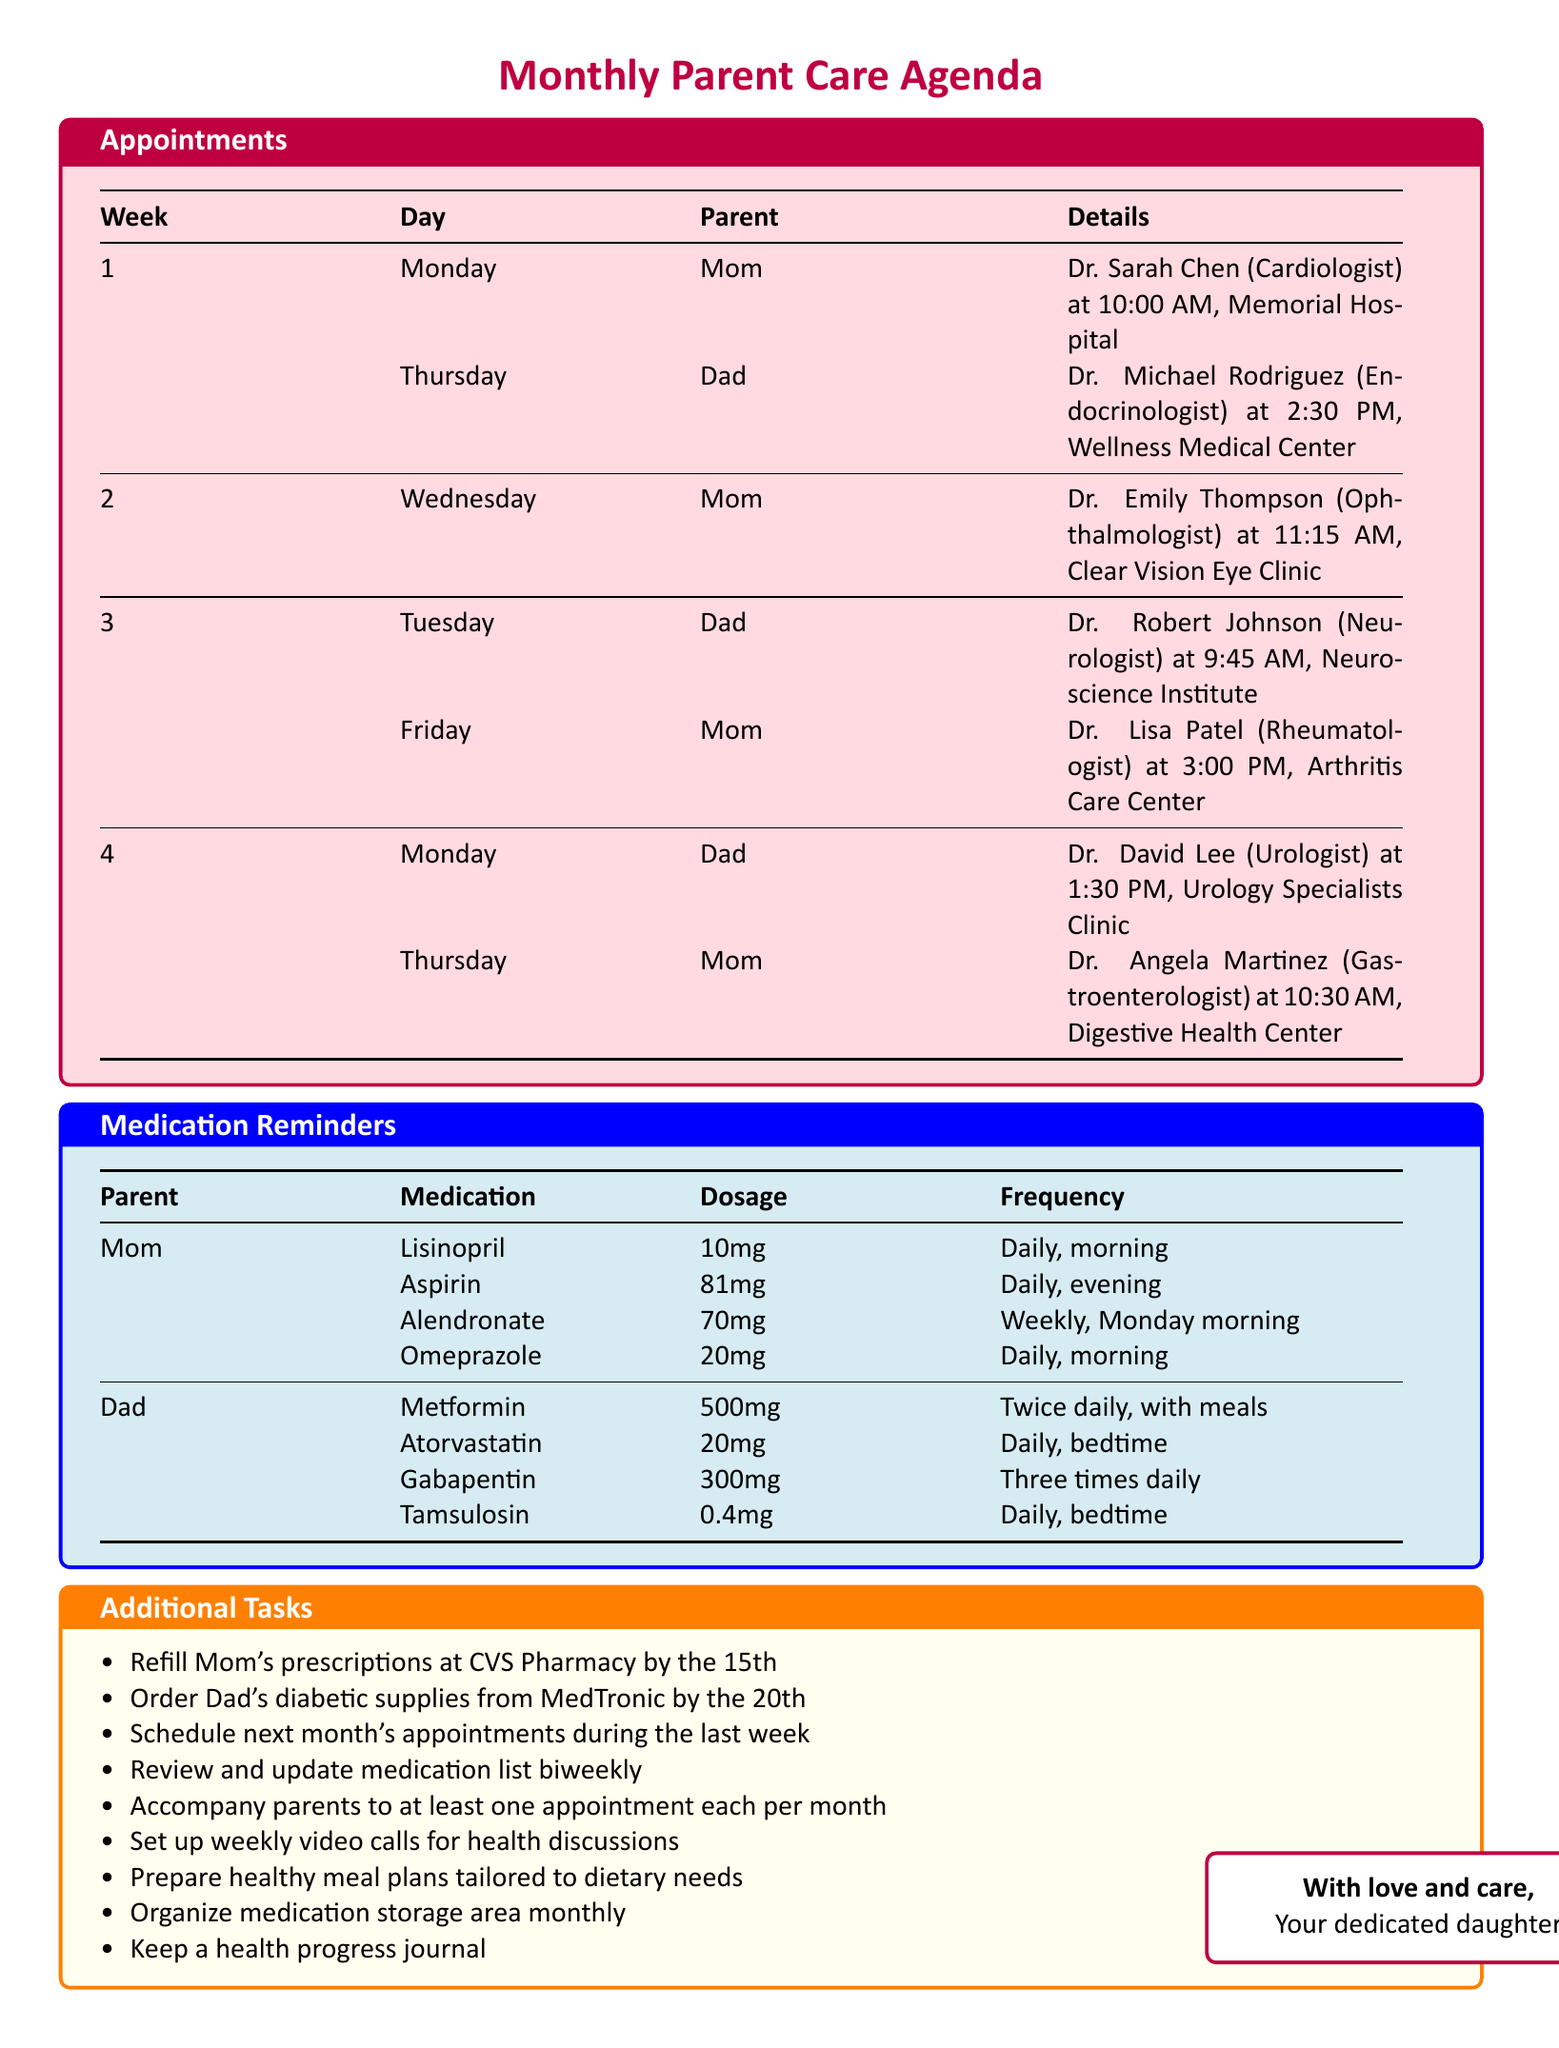What is Mom's first doctor's appointment? Mom's first appointment is with Dr. Sarah Chen, a Cardiologist, on Monday at 10:00 AM.
Answer: Dr. Sarah Chen What medication does Dad take in the evening? Dad takes Atorvastatin, 20mg, daily at bedtime.
Answer: Atorvastatin On which day does Dad have his Neurologist appointment? Dad's Neurologist appointment is scheduled for Tuesday of week 3.
Answer: Tuesday How often should Mom take Alendronate? Mom should take Alendronate, 70mg, weekly on Monday morning.
Answer: Weekly What task is scheduled for the 15th of each month? The task to refill Mom's prescriptions at CVS Pharmacy is scheduled for the 15th of each month.
Answer: Refill Mom's prescriptions Which week does Mom visit the Ophthalmologist? Mom visits the Ophthalmologist during the second week on Wednesday.
Answer: Week 2 What is the location of Dad's Endocrinologist appointment? Dad's Endocrinologist appointment is at Wellness Medical Center.
Answer: Wellness Medical Center How many times a day should Dad take Metformin? Dad should take Metformin twice daily with meals.
Answer: Twice daily What is one of the additional tasks regarding health discussions? One additional task is to set up weekly video calls to discuss health concerns.
Answer: Weekly video calls 